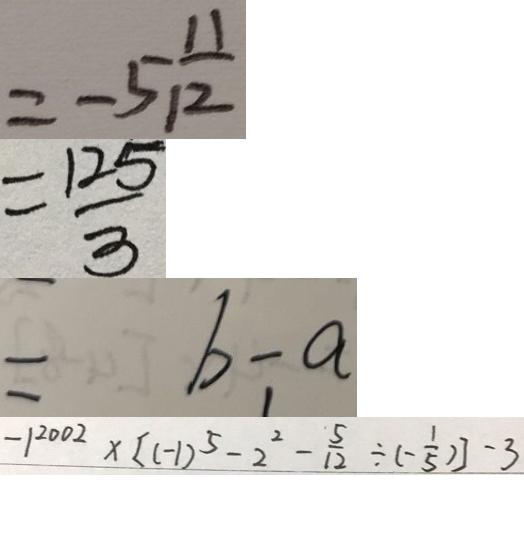<formula> <loc_0><loc_0><loc_500><loc_500>= - 5 \frac { 1 1 } { 1 2 } 
 = \frac { 1 2 5 } { 3 } 
 = b - a 
 - 1 ^ { 2 0 0 2 } \times [ ( - 1 ) ^ { 5 } - 2 ^ { 2 } - \frac { 5 } { 1 2 } \div ( - \frac { 1 } { 5 } ) ] - 3</formula> 